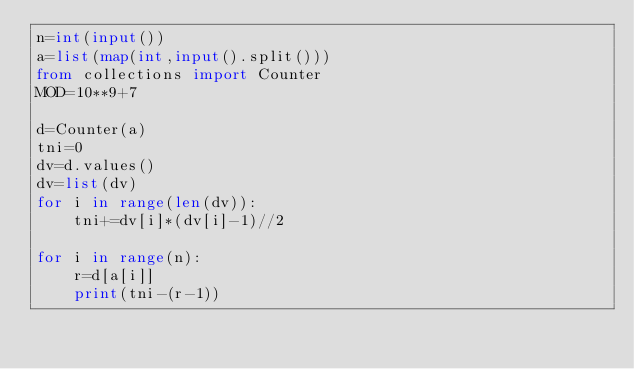Convert code to text. <code><loc_0><loc_0><loc_500><loc_500><_Python_>n=int(input())
a=list(map(int,input().split()))
from collections import Counter
MOD=10**9+7

d=Counter(a)
tni=0
dv=d.values()
dv=list(dv)
for i in range(len(dv)):
    tni+=dv[i]*(dv[i]-1)//2

for i in range(n):
    r=d[a[i]]
    print(tni-(r-1))

</code> 